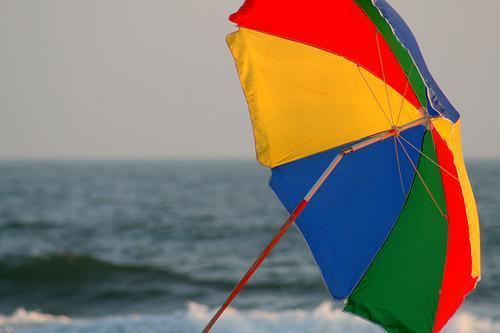How many different colors are there?
Give a very brief answer. 4. 